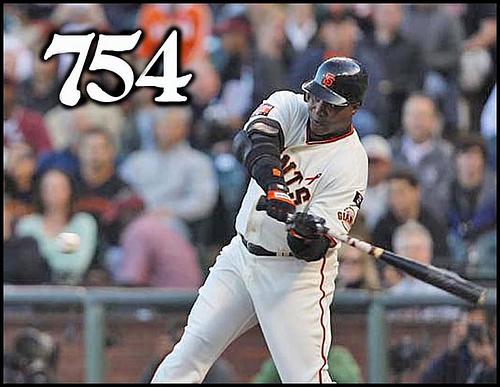Is the batter about to swing?
Be succinct. Yes. What is the number on the picture?
Answer briefly. 754. Is he a professional baseball player?
Quick response, please. Yes. Is the player left or right handed?
Give a very brief answer. Left. What color is the photo?
Be succinct. Colored. Why does he wear a brace on his right elbow?
Short answer required. Injury prevention. What team does this baseball player play for?
Keep it brief. Giants. Is the man swinging his baseball bat?
Quick response, please. Yes. 